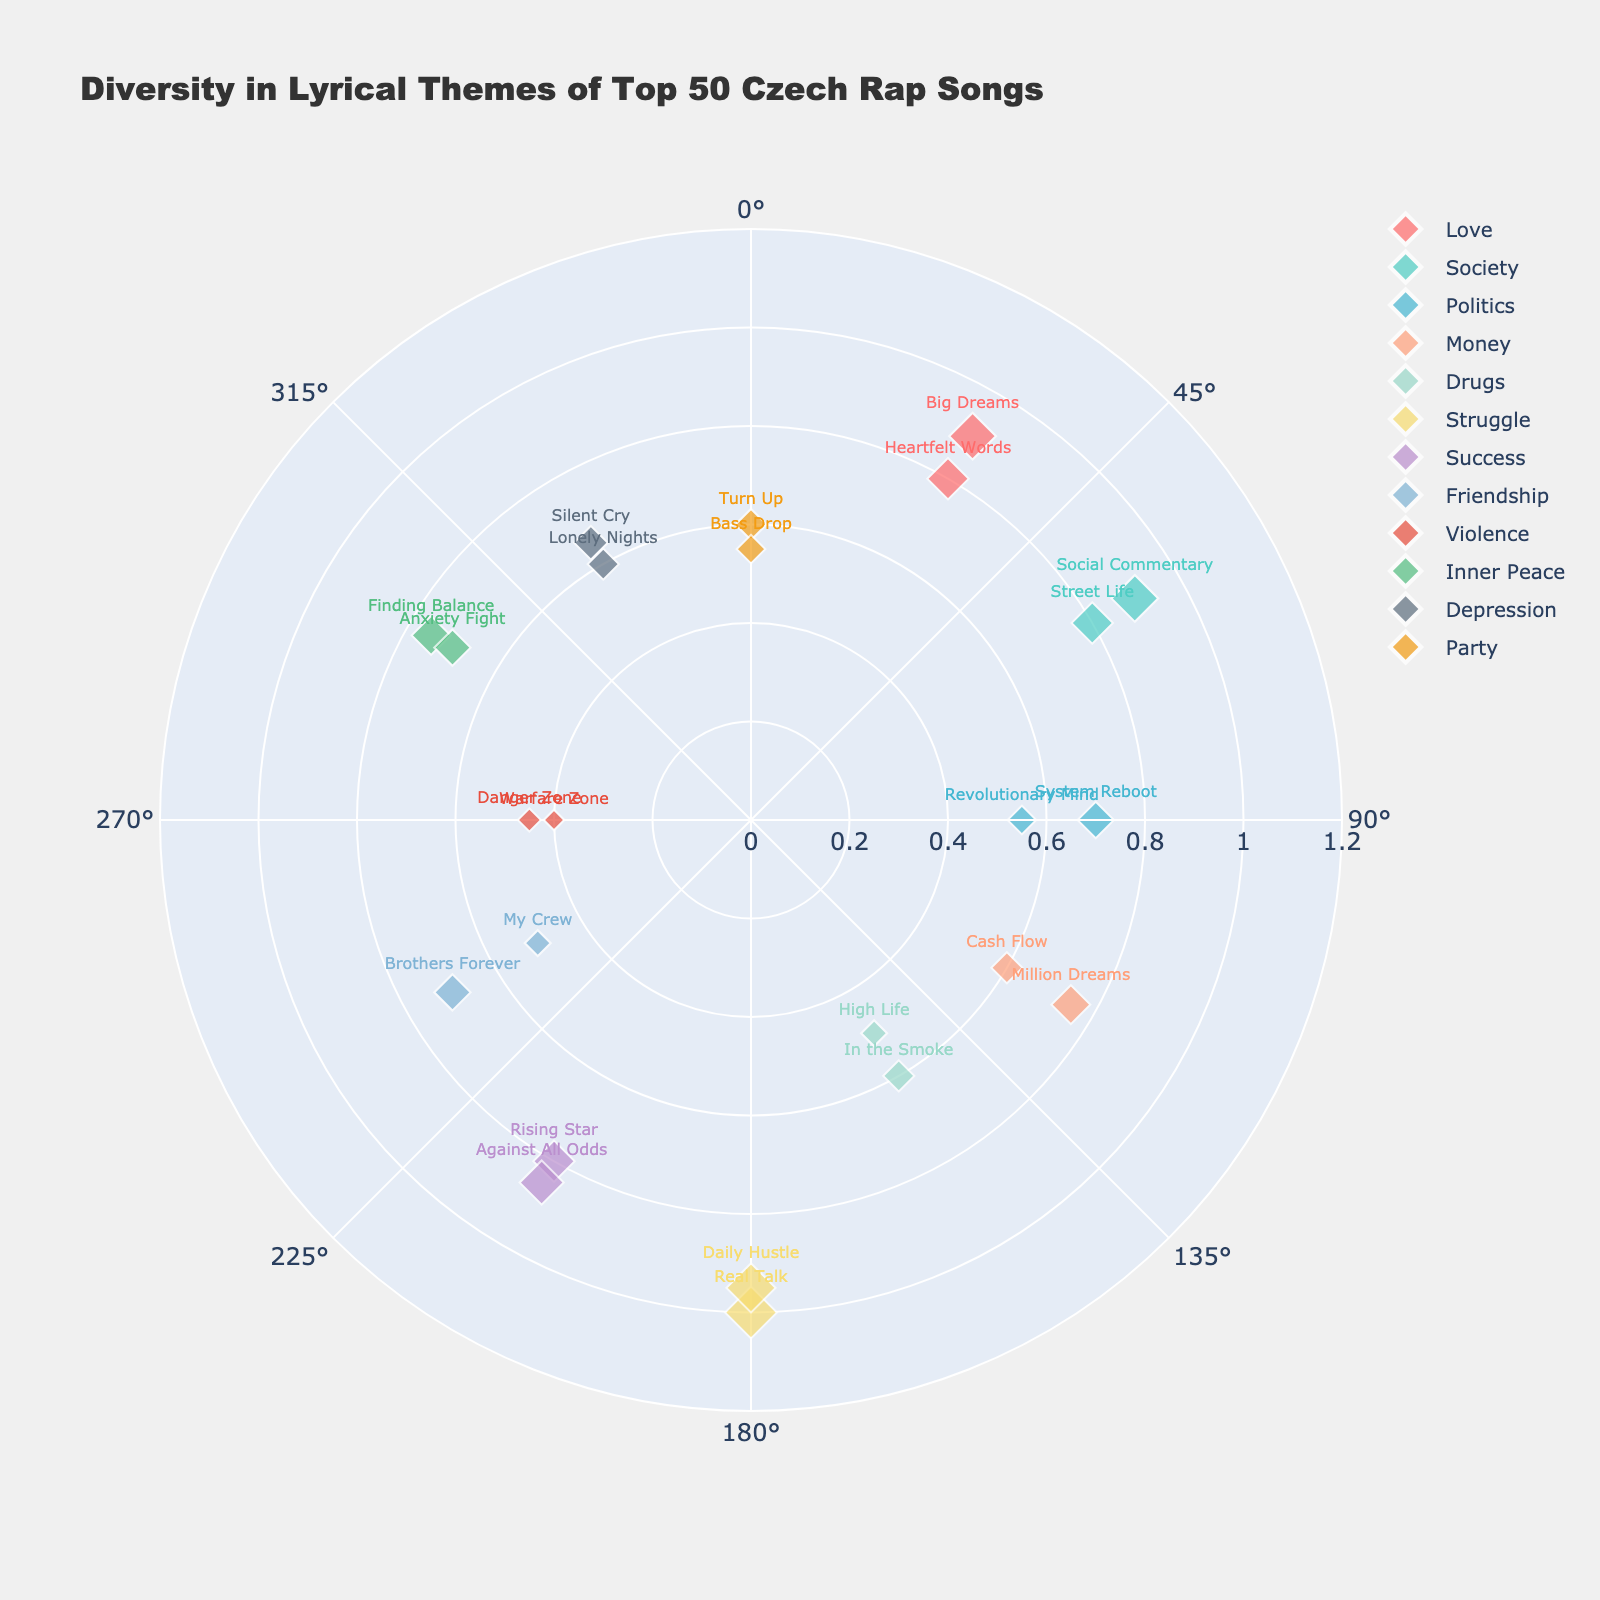What is the title of the figure? Simply look at the top of the figure to find the title, which usually summarizes the content of the chart.
Answer: "Diversity in Lyrical Themes of Top 50 Czech Rap Songs" Which theme has the highest radius value? Check the points farthest from the center; the theme "Struggle" has the highest radius (1.0).
Answer: Struggle How many different themes are represented in the plot? Count the unique themes listed in the legend or directly from the text labels on the plot.
Answer: 12 What theme corresponds to an angle of 150 degrees and a radius of 0.6? Find the data point at 150 degrees and see which theme and song title it corresponds to.
Answer: Drugs ("In the Smoke") Which themes have more than one song? Look at the plot or legend and identify themes that appear more than once.
Answer: Love, Society, Politics, Money, Drugs, Struggle, Friendship, Violence, Inner Peace, Depression, Party Which song has the smallest radius, and what theme does it belong to? Identify the smallest radius value and see which song title and theme are associated with this point.
Answer: Warfare Zone, Violence How does the representation of 'Love' compare to 'Party' in terms of radius values? Check the radial distances for songs under both 'Love' and 'Party' and compare the values.
Answer: 'Love' has 0.9 and 0.8; 'Party' has 0.6 and 0.55 What song themes occupy the maximum and minimum angles on the chart? Find songs at the beginning (0 or 360 degrees) and end of the angle scale (360 degrees).
Answer: Love at 30 degrees, Party at 360 degrees Which theme covers a mid-range radius of approximately 0.7 to 0.75? Look for points with radius values between 0.7 and 0.75 and identify the themes associated with those points.
Answer: Politics, Society, Inner Peace How many songs with 'Money' as a theme are plotted on the chart? Count the number of data points labeled 'Money'.
Answer: 2 